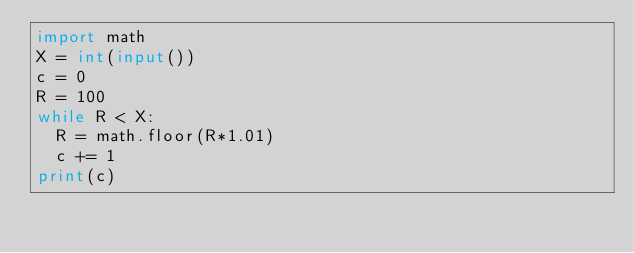<code> <loc_0><loc_0><loc_500><loc_500><_Python_>import math
X = int(input())
c = 0
R = 100
while R < X:
  R = math.floor(R*1.01)
  c += 1
print(c)</code> 